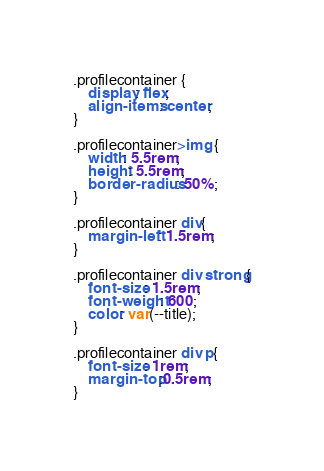<code> <loc_0><loc_0><loc_500><loc_500><_CSS_>.profilecontainer {
    display: flex;
    align-items: center;
}

.profilecontainer>img {
    width: 5.5rem;
    height: 5.5rem;
    border-radius: 50%;
}

.profilecontainer div{
    margin-left: 1.5rem;
}

.profilecontainer div strong{
    font-size: 1.5rem;
    font-weight: 600;
    color: var(--title);
}

.profilecontainer div p{
    font-size: 1rem;
    margin-top:0.5rem;
}
</code> 